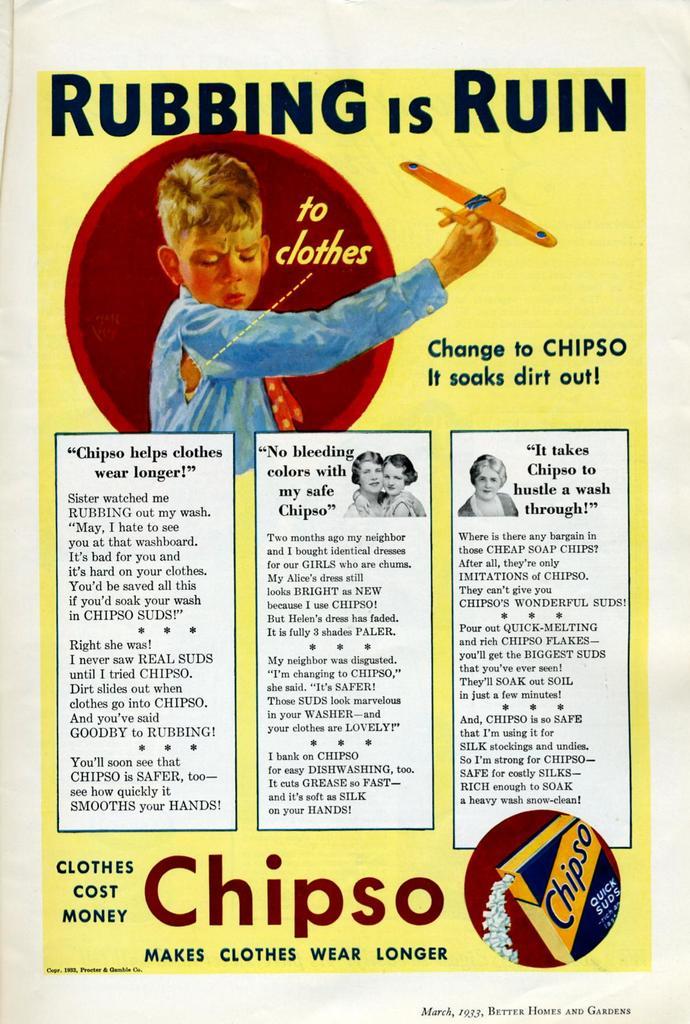Is chipso really effective?
Offer a very short reply. Yes. 